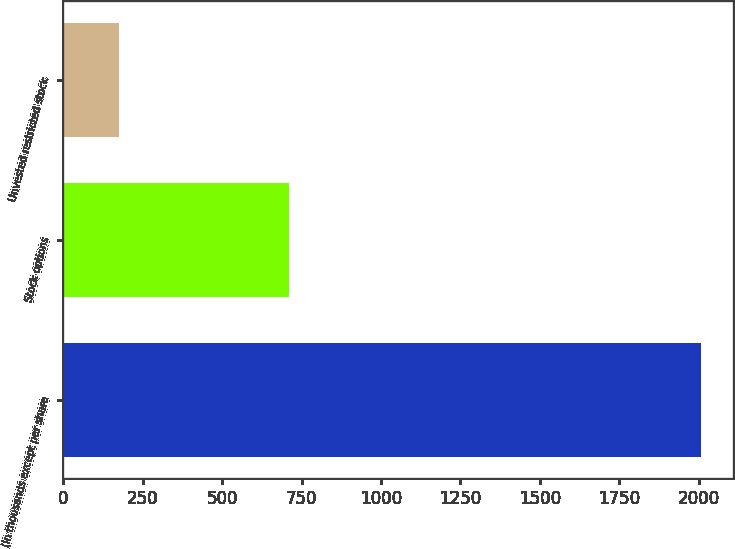<chart> <loc_0><loc_0><loc_500><loc_500><bar_chart><fcel>(In thousands except per share<fcel>Stock options<fcel>Unvested restricted stock<nl><fcel>2006<fcel>709<fcel>177<nl></chart> 